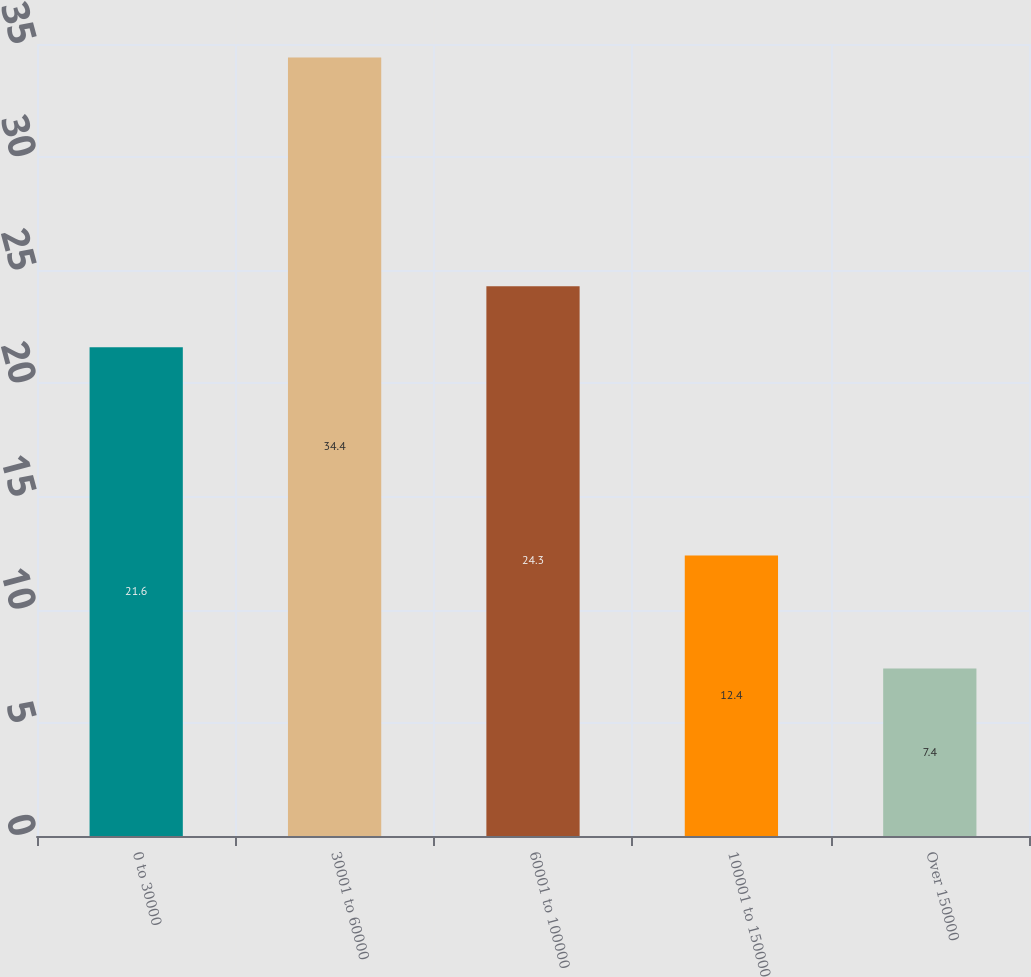<chart> <loc_0><loc_0><loc_500><loc_500><bar_chart><fcel>0 to 30000<fcel>30001 to 60000<fcel>60001 to 100000<fcel>100001 to 150000<fcel>Over 150000<nl><fcel>21.6<fcel>34.4<fcel>24.3<fcel>12.4<fcel>7.4<nl></chart> 